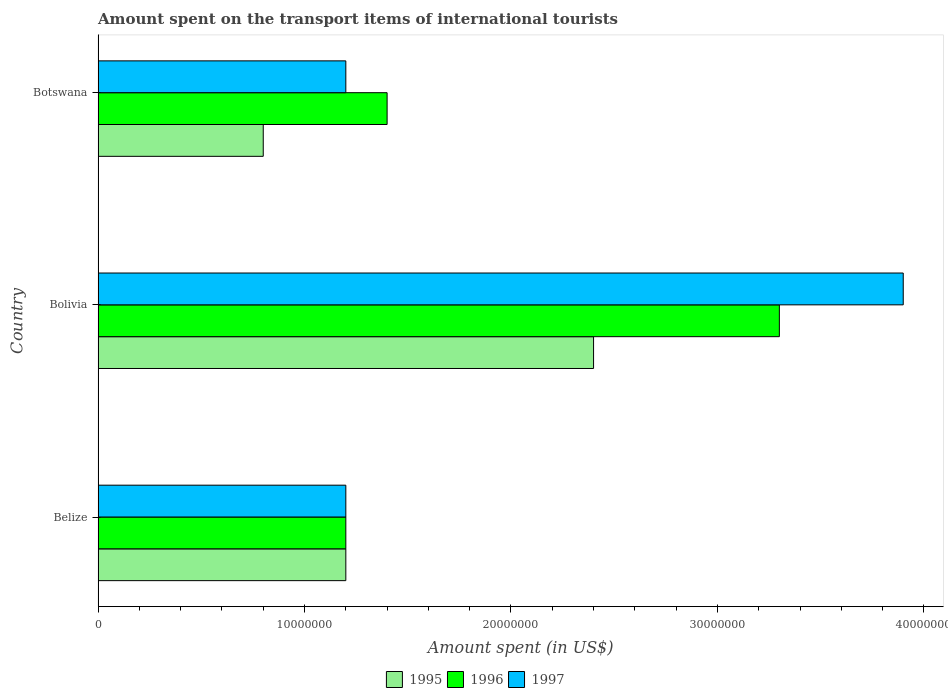How many different coloured bars are there?
Your response must be concise. 3. How many groups of bars are there?
Make the answer very short. 3. Are the number of bars per tick equal to the number of legend labels?
Give a very brief answer. Yes. How many bars are there on the 3rd tick from the bottom?
Your answer should be very brief. 3. What is the label of the 3rd group of bars from the top?
Ensure brevity in your answer.  Belize. What is the amount spent on the transport items of international tourists in 1997 in Bolivia?
Your answer should be compact. 3.90e+07. Across all countries, what is the maximum amount spent on the transport items of international tourists in 1996?
Make the answer very short. 3.30e+07. In which country was the amount spent on the transport items of international tourists in 1996 maximum?
Offer a terse response. Bolivia. In which country was the amount spent on the transport items of international tourists in 1997 minimum?
Make the answer very short. Belize. What is the total amount spent on the transport items of international tourists in 1996 in the graph?
Provide a short and direct response. 5.90e+07. What is the difference between the amount spent on the transport items of international tourists in 1996 in Bolivia and that in Botswana?
Keep it short and to the point. 1.90e+07. What is the difference between the amount spent on the transport items of international tourists in 1995 in Belize and the amount spent on the transport items of international tourists in 1996 in Botswana?
Offer a very short reply. -2.00e+06. What is the average amount spent on the transport items of international tourists in 1995 per country?
Provide a succinct answer. 1.47e+07. What is the ratio of the amount spent on the transport items of international tourists in 1997 in Bolivia to that in Botswana?
Offer a very short reply. 3.25. Is the amount spent on the transport items of international tourists in 1996 in Belize less than that in Bolivia?
Your response must be concise. Yes. What is the difference between the highest and the second highest amount spent on the transport items of international tourists in 1995?
Offer a terse response. 1.20e+07. What is the difference between the highest and the lowest amount spent on the transport items of international tourists in 1995?
Make the answer very short. 1.60e+07. Is the sum of the amount spent on the transport items of international tourists in 1995 in Belize and Bolivia greater than the maximum amount spent on the transport items of international tourists in 1996 across all countries?
Offer a very short reply. Yes. What does the 1st bar from the bottom in Bolivia represents?
Offer a very short reply. 1995. Is it the case that in every country, the sum of the amount spent on the transport items of international tourists in 1996 and amount spent on the transport items of international tourists in 1995 is greater than the amount spent on the transport items of international tourists in 1997?
Provide a succinct answer. Yes. How many bars are there?
Offer a very short reply. 9. Are all the bars in the graph horizontal?
Make the answer very short. Yes. How many countries are there in the graph?
Ensure brevity in your answer.  3. What is the difference between two consecutive major ticks on the X-axis?
Your answer should be compact. 1.00e+07. Where does the legend appear in the graph?
Offer a terse response. Bottom center. What is the title of the graph?
Give a very brief answer. Amount spent on the transport items of international tourists. What is the label or title of the X-axis?
Give a very brief answer. Amount spent (in US$). What is the label or title of the Y-axis?
Make the answer very short. Country. What is the Amount spent (in US$) in 1996 in Belize?
Keep it short and to the point. 1.20e+07. What is the Amount spent (in US$) of 1995 in Bolivia?
Offer a very short reply. 2.40e+07. What is the Amount spent (in US$) in 1996 in Bolivia?
Provide a short and direct response. 3.30e+07. What is the Amount spent (in US$) in 1997 in Bolivia?
Your answer should be very brief. 3.90e+07. What is the Amount spent (in US$) in 1996 in Botswana?
Your response must be concise. 1.40e+07. What is the Amount spent (in US$) in 1997 in Botswana?
Provide a short and direct response. 1.20e+07. Across all countries, what is the maximum Amount spent (in US$) of 1995?
Your response must be concise. 2.40e+07. Across all countries, what is the maximum Amount spent (in US$) of 1996?
Your answer should be very brief. 3.30e+07. Across all countries, what is the maximum Amount spent (in US$) of 1997?
Your answer should be compact. 3.90e+07. Across all countries, what is the minimum Amount spent (in US$) in 1995?
Offer a very short reply. 8.00e+06. Across all countries, what is the minimum Amount spent (in US$) in 1997?
Your answer should be very brief. 1.20e+07. What is the total Amount spent (in US$) of 1995 in the graph?
Ensure brevity in your answer.  4.40e+07. What is the total Amount spent (in US$) of 1996 in the graph?
Your answer should be compact. 5.90e+07. What is the total Amount spent (in US$) of 1997 in the graph?
Give a very brief answer. 6.30e+07. What is the difference between the Amount spent (in US$) of 1995 in Belize and that in Bolivia?
Provide a short and direct response. -1.20e+07. What is the difference between the Amount spent (in US$) of 1996 in Belize and that in Bolivia?
Make the answer very short. -2.10e+07. What is the difference between the Amount spent (in US$) of 1997 in Belize and that in Bolivia?
Provide a succinct answer. -2.70e+07. What is the difference between the Amount spent (in US$) of 1996 in Belize and that in Botswana?
Your answer should be very brief. -2.00e+06. What is the difference between the Amount spent (in US$) of 1997 in Belize and that in Botswana?
Give a very brief answer. 0. What is the difference between the Amount spent (in US$) of 1995 in Bolivia and that in Botswana?
Ensure brevity in your answer.  1.60e+07. What is the difference between the Amount spent (in US$) of 1996 in Bolivia and that in Botswana?
Give a very brief answer. 1.90e+07. What is the difference between the Amount spent (in US$) in 1997 in Bolivia and that in Botswana?
Keep it short and to the point. 2.70e+07. What is the difference between the Amount spent (in US$) in 1995 in Belize and the Amount spent (in US$) in 1996 in Bolivia?
Provide a short and direct response. -2.10e+07. What is the difference between the Amount spent (in US$) of 1995 in Belize and the Amount spent (in US$) of 1997 in Bolivia?
Provide a succinct answer. -2.70e+07. What is the difference between the Amount spent (in US$) of 1996 in Belize and the Amount spent (in US$) of 1997 in Bolivia?
Offer a very short reply. -2.70e+07. What is the difference between the Amount spent (in US$) in 1995 in Belize and the Amount spent (in US$) in 1996 in Botswana?
Provide a short and direct response. -2.00e+06. What is the difference between the Amount spent (in US$) of 1996 in Belize and the Amount spent (in US$) of 1997 in Botswana?
Keep it short and to the point. 0. What is the difference between the Amount spent (in US$) of 1996 in Bolivia and the Amount spent (in US$) of 1997 in Botswana?
Your answer should be very brief. 2.10e+07. What is the average Amount spent (in US$) of 1995 per country?
Give a very brief answer. 1.47e+07. What is the average Amount spent (in US$) of 1996 per country?
Provide a short and direct response. 1.97e+07. What is the average Amount spent (in US$) in 1997 per country?
Offer a terse response. 2.10e+07. What is the difference between the Amount spent (in US$) in 1995 and Amount spent (in US$) in 1996 in Belize?
Make the answer very short. 0. What is the difference between the Amount spent (in US$) of 1995 and Amount spent (in US$) of 1996 in Bolivia?
Offer a terse response. -9.00e+06. What is the difference between the Amount spent (in US$) in 1995 and Amount spent (in US$) in 1997 in Bolivia?
Provide a short and direct response. -1.50e+07. What is the difference between the Amount spent (in US$) in 1996 and Amount spent (in US$) in 1997 in Bolivia?
Make the answer very short. -6.00e+06. What is the difference between the Amount spent (in US$) of 1995 and Amount spent (in US$) of 1996 in Botswana?
Provide a succinct answer. -6.00e+06. What is the difference between the Amount spent (in US$) in 1995 and Amount spent (in US$) in 1997 in Botswana?
Make the answer very short. -4.00e+06. What is the difference between the Amount spent (in US$) of 1996 and Amount spent (in US$) of 1997 in Botswana?
Offer a terse response. 2.00e+06. What is the ratio of the Amount spent (in US$) in 1995 in Belize to that in Bolivia?
Offer a very short reply. 0.5. What is the ratio of the Amount spent (in US$) in 1996 in Belize to that in Bolivia?
Your answer should be very brief. 0.36. What is the ratio of the Amount spent (in US$) of 1997 in Belize to that in Bolivia?
Your response must be concise. 0.31. What is the ratio of the Amount spent (in US$) in 1996 in Bolivia to that in Botswana?
Offer a terse response. 2.36. What is the difference between the highest and the second highest Amount spent (in US$) of 1996?
Make the answer very short. 1.90e+07. What is the difference between the highest and the second highest Amount spent (in US$) of 1997?
Give a very brief answer. 2.70e+07. What is the difference between the highest and the lowest Amount spent (in US$) in 1995?
Provide a short and direct response. 1.60e+07. What is the difference between the highest and the lowest Amount spent (in US$) in 1996?
Make the answer very short. 2.10e+07. What is the difference between the highest and the lowest Amount spent (in US$) in 1997?
Your response must be concise. 2.70e+07. 